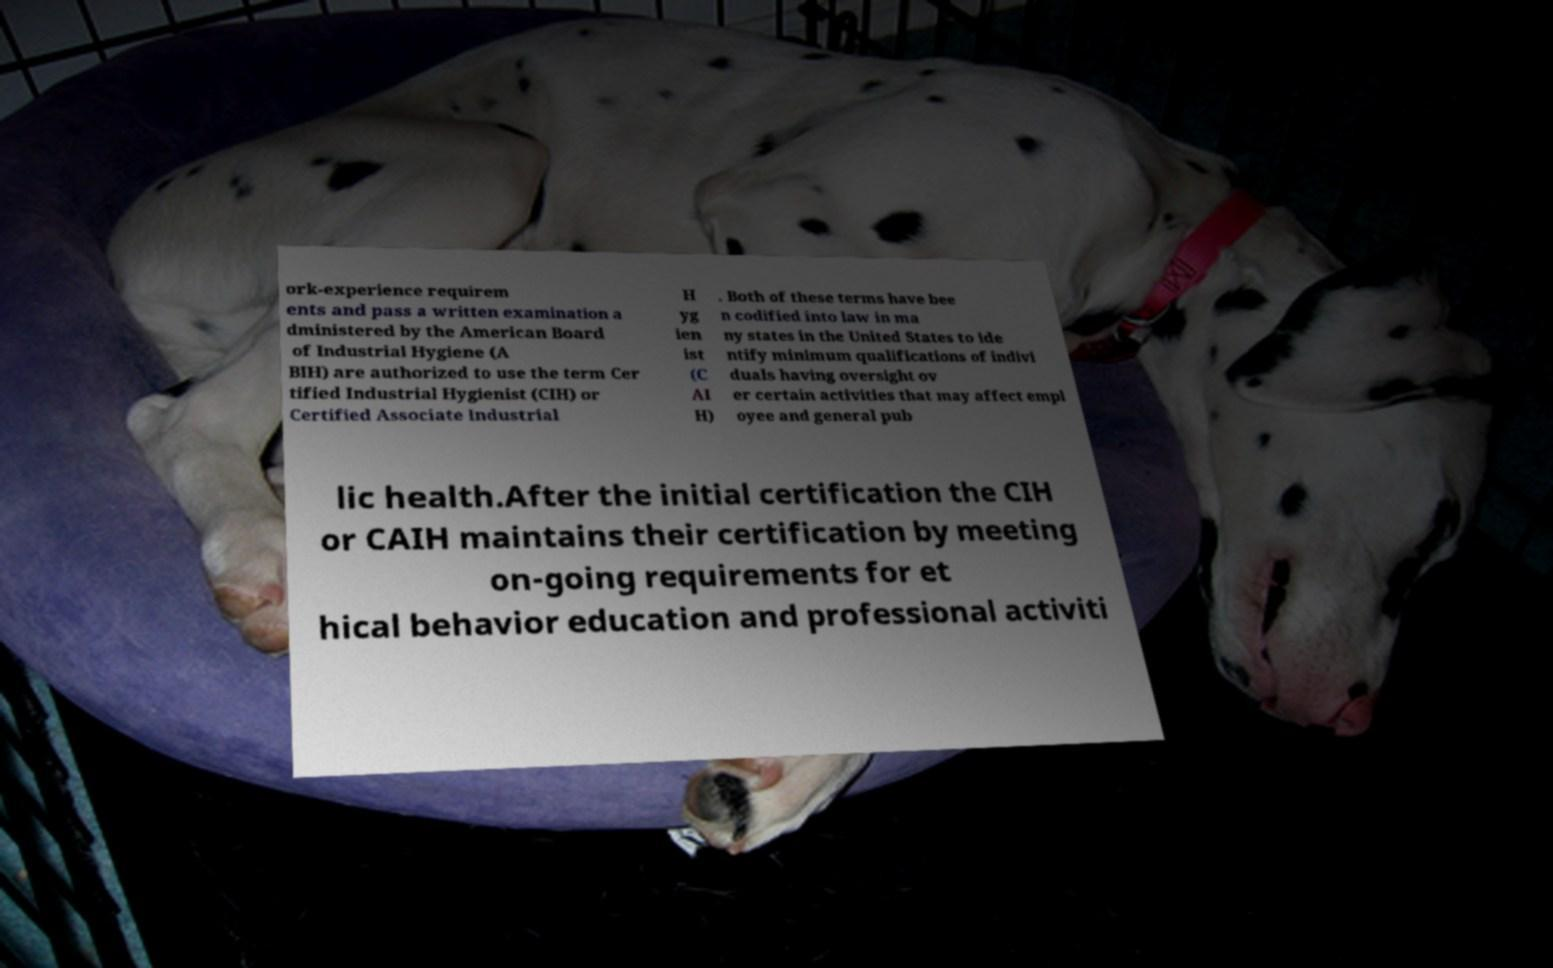For documentation purposes, I need the text within this image transcribed. Could you provide that? ork-experience requirem ents and pass a written examination a dministered by the American Board of Industrial Hygiene (A BIH) are authorized to use the term Cer tified Industrial Hygienist (CIH) or Certified Associate Industrial H yg ien ist (C AI H) . Both of these terms have bee n codified into law in ma ny states in the United States to ide ntify minimum qualifications of indivi duals having oversight ov er certain activities that may affect empl oyee and general pub lic health.After the initial certification the CIH or CAIH maintains their certification by meeting on-going requirements for et hical behavior education and professional activiti 